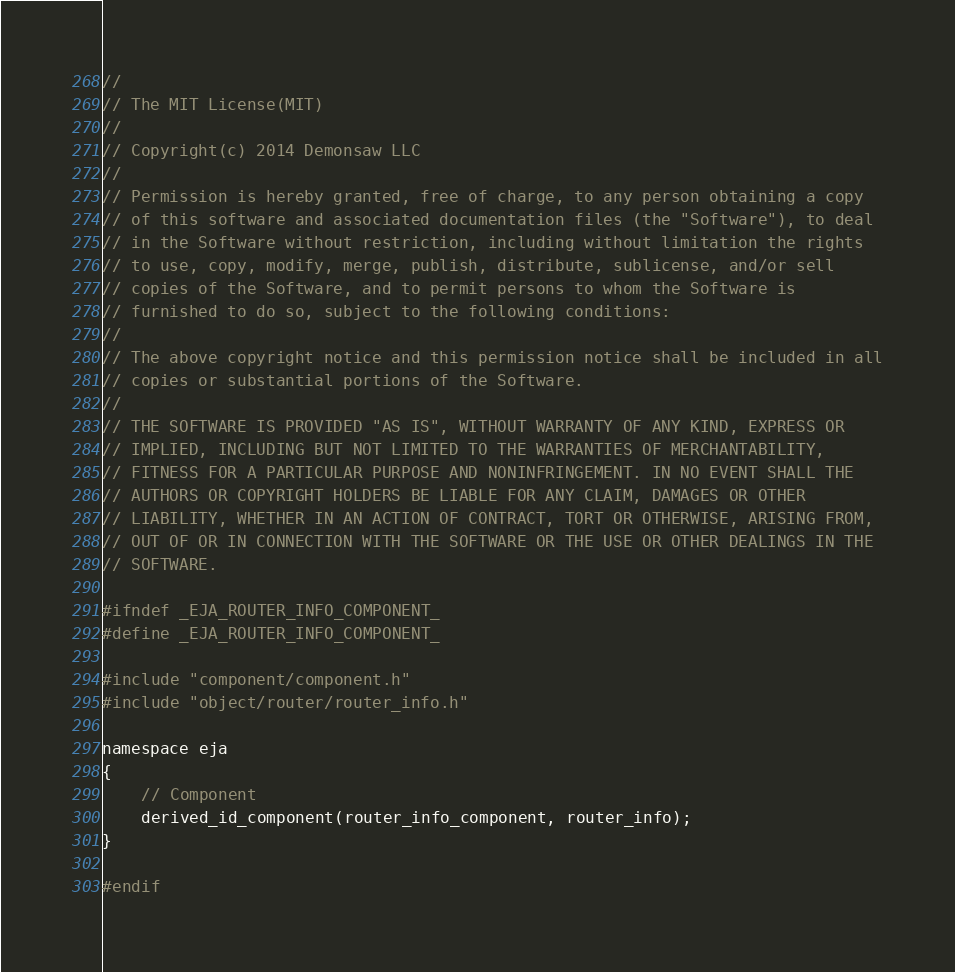<code> <loc_0><loc_0><loc_500><loc_500><_C_>//
// The MIT License(MIT)
//
// Copyright(c) 2014 Demonsaw LLC
//
// Permission is hereby granted, free of charge, to any person obtaining a copy
// of this software and associated documentation files (the "Software"), to deal
// in the Software without restriction, including without limitation the rights
// to use, copy, modify, merge, publish, distribute, sublicense, and/or sell
// copies of the Software, and to permit persons to whom the Software is
// furnished to do so, subject to the following conditions:
// 
// The above copyright notice and this permission notice shall be included in all
// copies or substantial portions of the Software.
// 
// THE SOFTWARE IS PROVIDED "AS IS", WITHOUT WARRANTY OF ANY KIND, EXPRESS OR
// IMPLIED, INCLUDING BUT NOT LIMITED TO THE WARRANTIES OF MERCHANTABILITY,
// FITNESS FOR A PARTICULAR PURPOSE AND NONINFRINGEMENT. IN NO EVENT SHALL THE
// AUTHORS OR COPYRIGHT HOLDERS BE LIABLE FOR ANY CLAIM, DAMAGES OR OTHER
// LIABILITY, WHETHER IN AN ACTION OF CONTRACT, TORT OR OTHERWISE, ARISING FROM,
// OUT OF OR IN CONNECTION WITH THE SOFTWARE OR THE USE OR OTHER DEALINGS IN THE
// SOFTWARE.

#ifndef _EJA_ROUTER_INFO_COMPONENT_
#define _EJA_ROUTER_INFO_COMPONENT_

#include "component/component.h"
#include "object/router/router_info.h"

namespace eja
{
	// Component
	derived_id_component(router_info_component, router_info);
}

#endif
</code> 